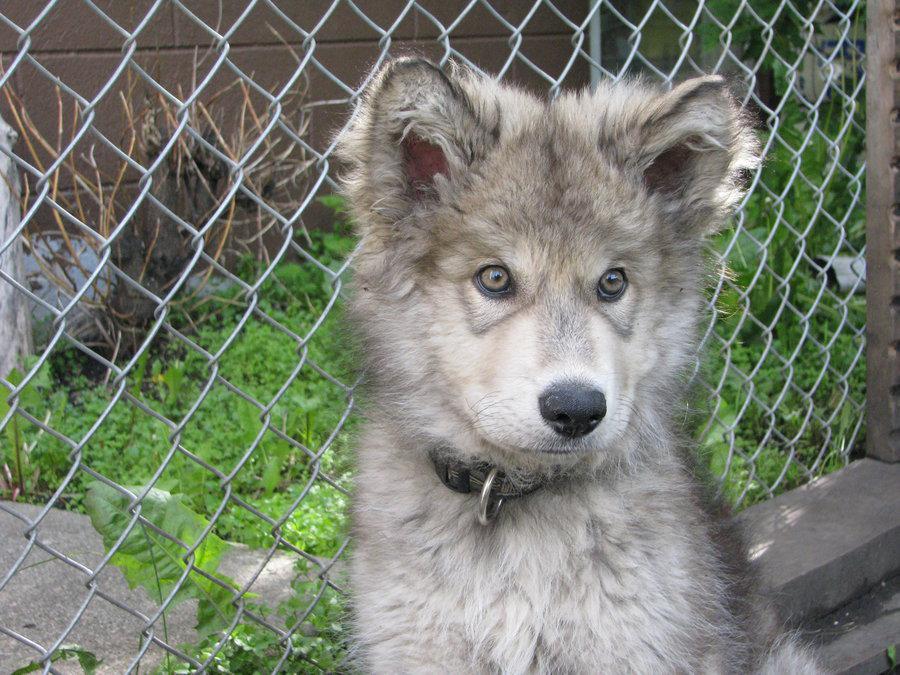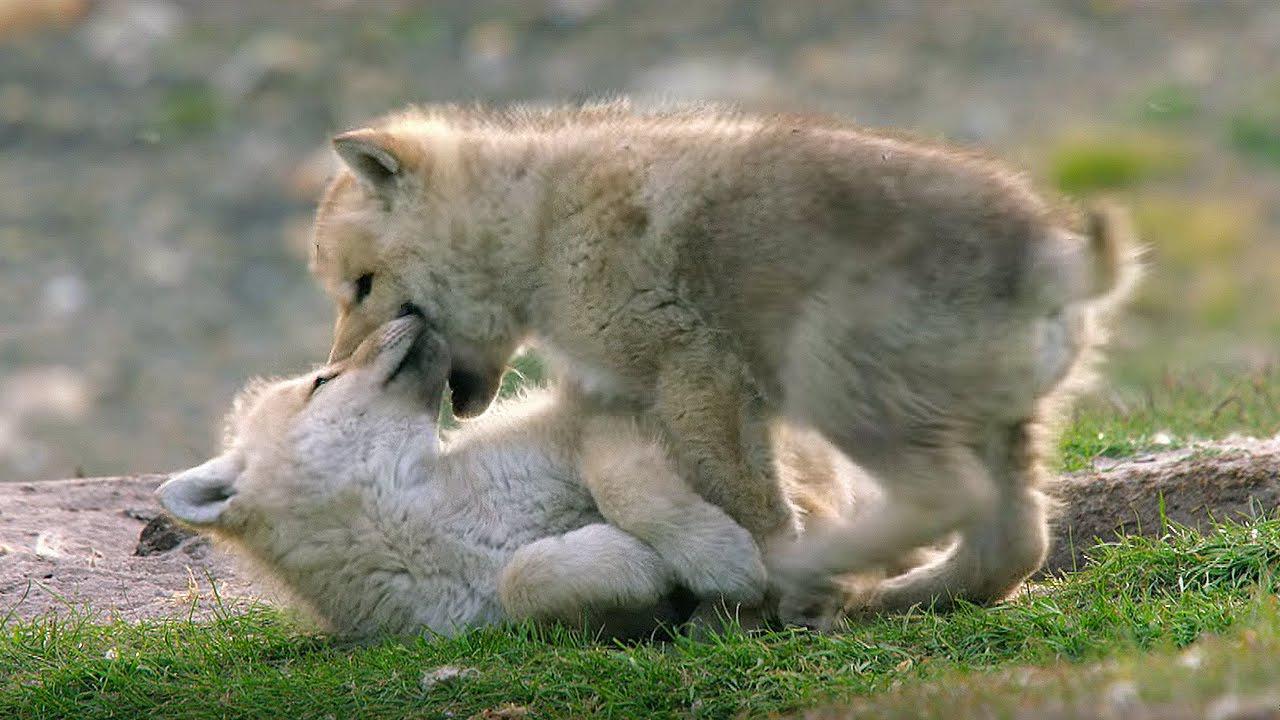The first image is the image on the left, the second image is the image on the right. Evaluate the accuracy of this statement regarding the images: "Left image contains two dogs and right image contains one dog.". Is it true? Answer yes or no. No. The first image is the image on the left, the second image is the image on the right. Examine the images to the left and right. Is the description "Fencing is in the background of one image." accurate? Answer yes or no. Yes. 